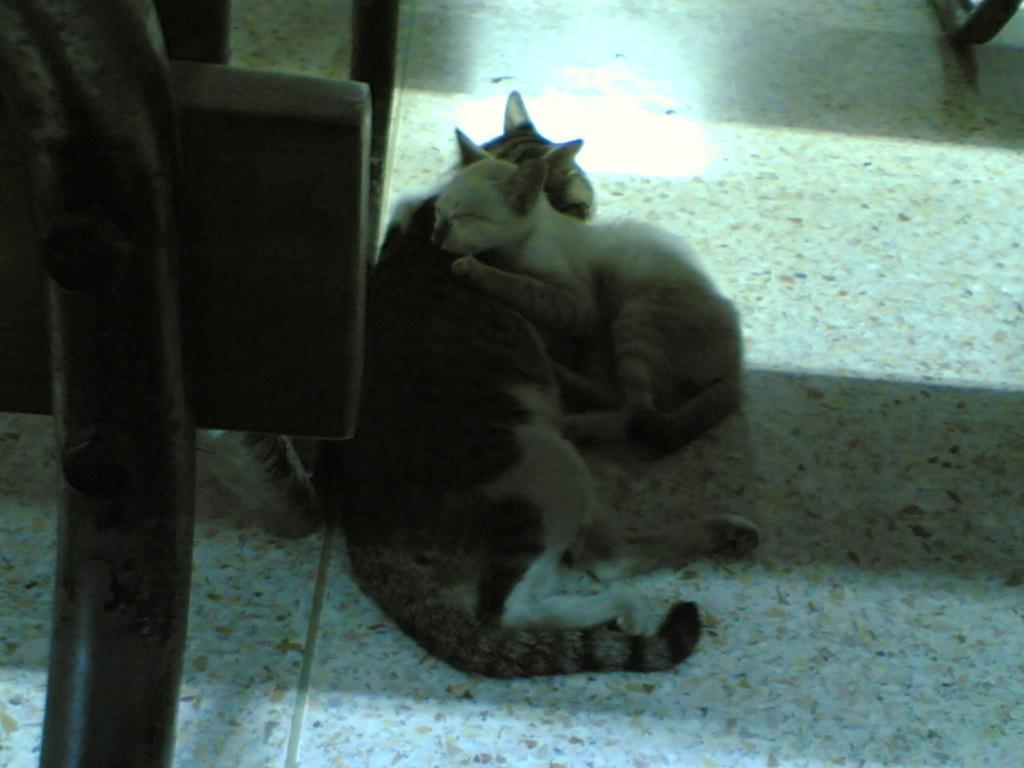Please provide a concise description of this image. In this image we can see cats lying on the floor one on another. 